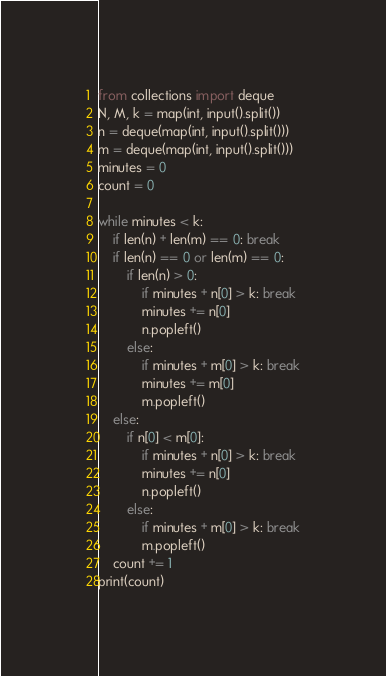<code> <loc_0><loc_0><loc_500><loc_500><_Python_>from collections import deque
N, M, k = map(int, input().split())
n = deque(map(int, input().split()))
m = deque(map(int, input().split()))
minutes = 0
count = 0

while minutes < k:
	if len(n) + len(m) == 0: break
	if len(n) == 0 or len(m) == 0:
		if len(n) > 0:
			if minutes + n[0] > k: break
			minutes += n[0]
			n.popleft()
		else:
			if minutes + m[0] > k: break
			minutes += m[0]
			m.popleft()
	else:
		if n[0] < m[0]:
			if minutes + n[0] > k: break
			minutes += n[0]
			n.popleft()
		else:
			if minutes + m[0] > k: break
			m.popleft()
	count += 1
print(count)</code> 